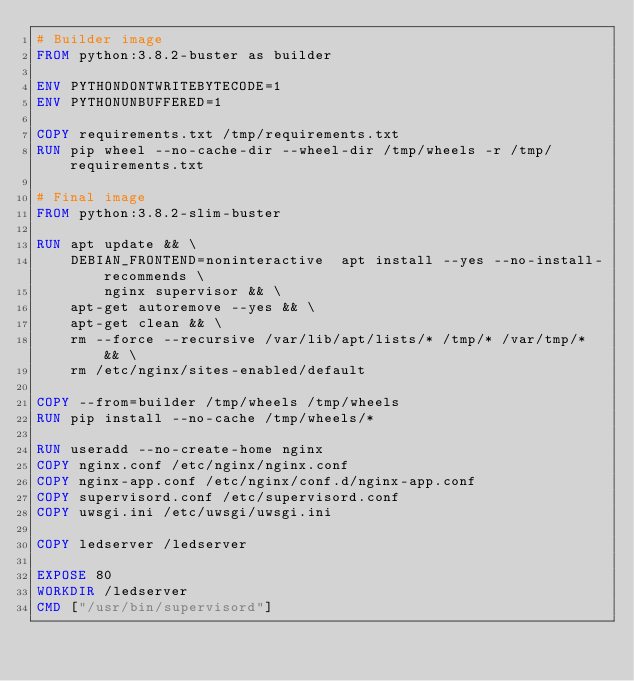Convert code to text. <code><loc_0><loc_0><loc_500><loc_500><_Dockerfile_># Builder image
FROM python:3.8.2-buster as builder

ENV PYTHONDONTWRITEBYTECODE=1
ENV PYTHONUNBUFFERED=1

COPY requirements.txt /tmp/requirements.txt
RUN pip wheel --no-cache-dir --wheel-dir /tmp/wheels -r /tmp/requirements.txt

# Final image
FROM python:3.8.2-slim-buster

RUN apt update && \
    DEBIAN_FRONTEND=noninteractive  apt install --yes --no-install-recommends \
        nginx supervisor && \
    apt-get autoremove --yes && \
    apt-get clean && \
    rm --force --recursive /var/lib/apt/lists/* /tmp/* /var/tmp/* && \
    rm /etc/nginx/sites-enabled/default

COPY --from=builder /tmp/wheels /tmp/wheels
RUN pip install --no-cache /tmp/wheels/*

RUN useradd --no-create-home nginx
COPY nginx.conf /etc/nginx/nginx.conf
COPY nginx-app.conf /etc/nginx/conf.d/nginx-app.conf
COPY supervisord.conf /etc/supervisord.conf
COPY uwsgi.ini /etc/uwsgi/uwsgi.ini

COPY ledserver /ledserver

EXPOSE 80
WORKDIR /ledserver
CMD ["/usr/bin/supervisord"]
</code> 